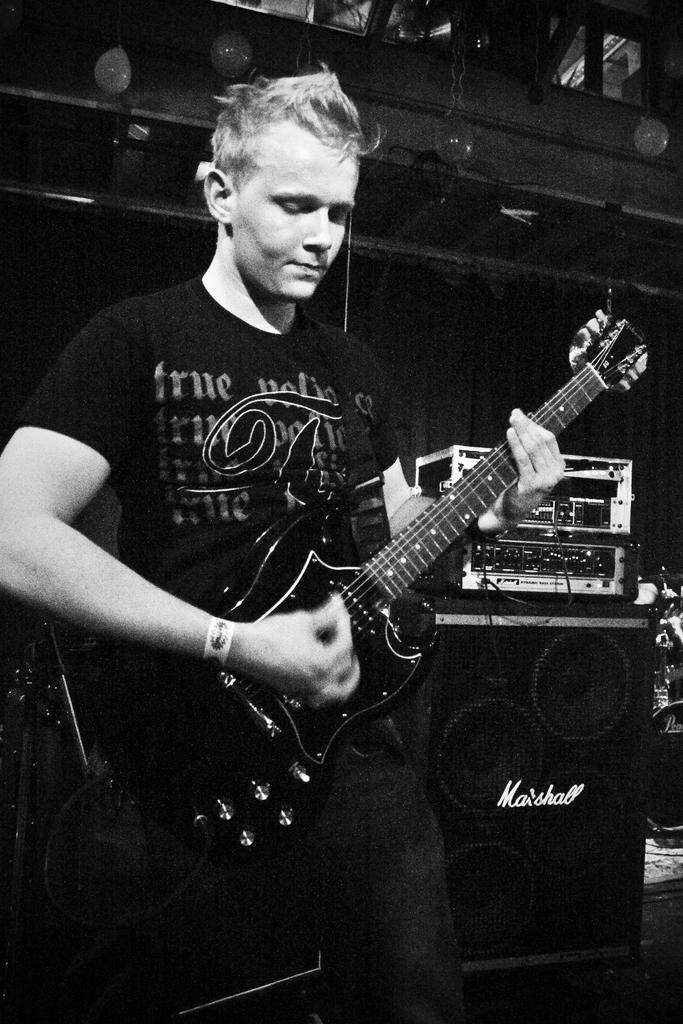What is the man in the image doing? The man is playing the guitar. What object is the man holding in the image? The man is holding a guitar. What can be seen in the background of the image? There is a speaker and music equipment hire in the background of the image. What type of plant is growing on the scale in the image? There is no scale or plant present in the image. How many eggs are visible in the image? There are no eggs visible in the image. 